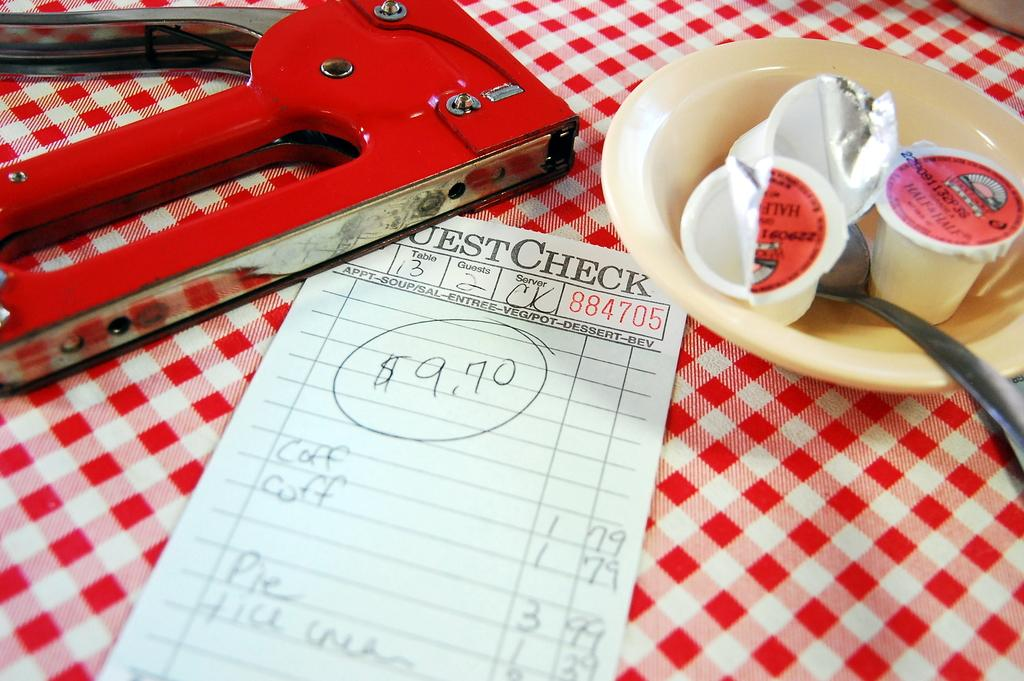<image>
Offer a succinct explanation of the picture presented. A food receipt for 9 dollars and 70 cents 